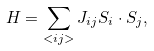Convert formula to latex. <formula><loc_0><loc_0><loc_500><loc_500>H = \sum _ { < i j > } J _ { i j } { S } _ { i } \cdot { S } _ { j } ,</formula> 